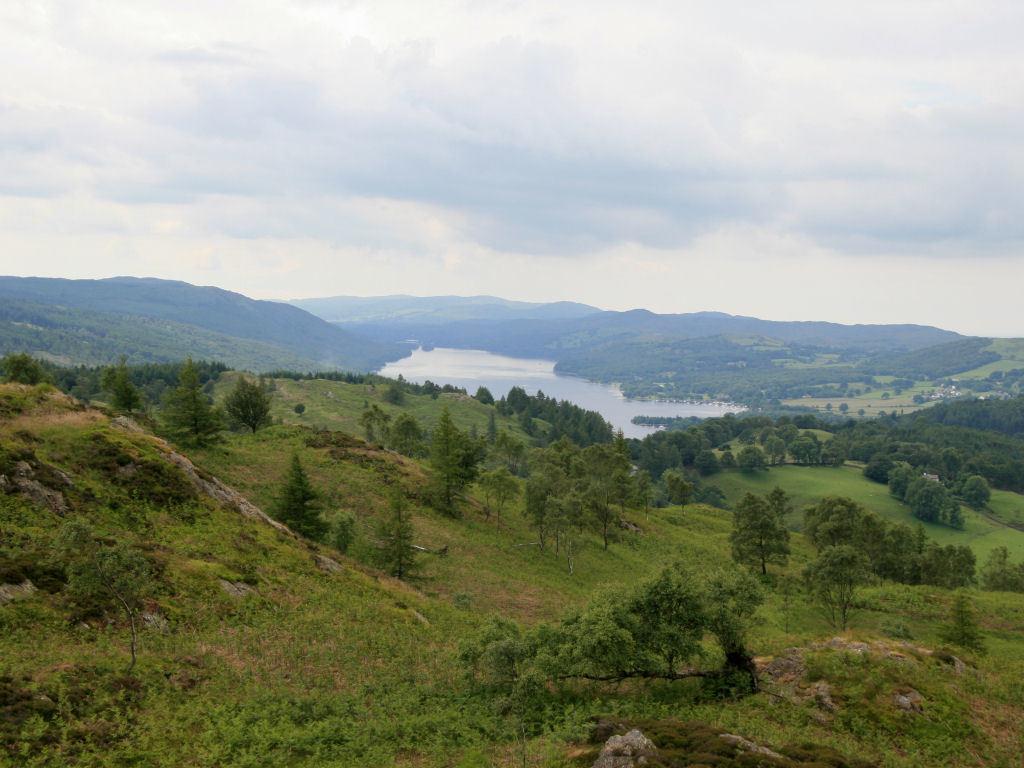Can you describe this image briefly? In the picture I can see trees, the grass and the water. In the background I can see hills and the sky. 